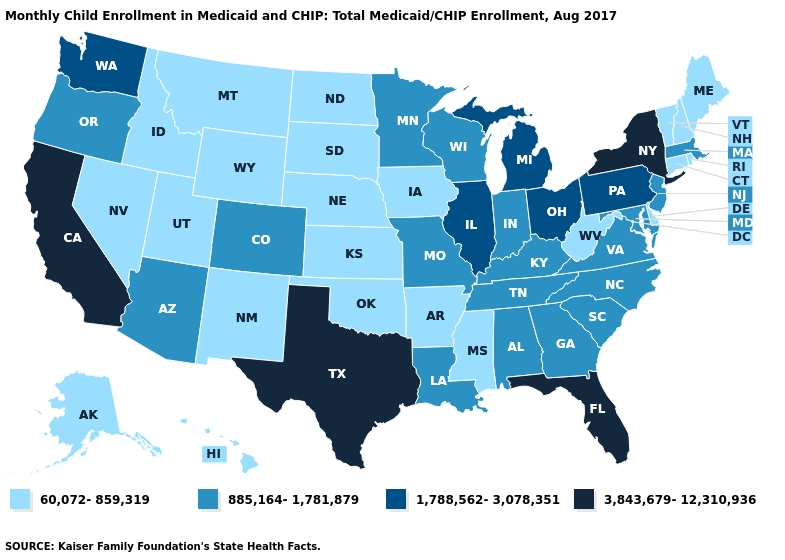What is the value of Minnesota?
Write a very short answer. 885,164-1,781,879. Which states have the lowest value in the USA?
Be succinct. Alaska, Arkansas, Connecticut, Delaware, Hawaii, Idaho, Iowa, Kansas, Maine, Mississippi, Montana, Nebraska, Nevada, New Hampshire, New Mexico, North Dakota, Oklahoma, Rhode Island, South Dakota, Utah, Vermont, West Virginia, Wyoming. How many symbols are there in the legend?
Concise answer only. 4. What is the value of Arkansas?
Be succinct. 60,072-859,319. What is the highest value in states that border Rhode Island?
Answer briefly. 885,164-1,781,879. Is the legend a continuous bar?
Concise answer only. No. Does Mississippi have the lowest value in the USA?
Answer briefly. Yes. Name the states that have a value in the range 1,788,562-3,078,351?
Give a very brief answer. Illinois, Michigan, Ohio, Pennsylvania, Washington. What is the value of Nevada?
Be succinct. 60,072-859,319. How many symbols are there in the legend?
Answer briefly. 4. What is the value of Minnesota?
Keep it brief. 885,164-1,781,879. What is the highest value in states that border Arkansas?
Keep it brief. 3,843,679-12,310,936. What is the lowest value in states that border Montana?
Keep it brief. 60,072-859,319. Among the states that border Wisconsin , which have the highest value?
Keep it brief. Illinois, Michigan. How many symbols are there in the legend?
Concise answer only. 4. 